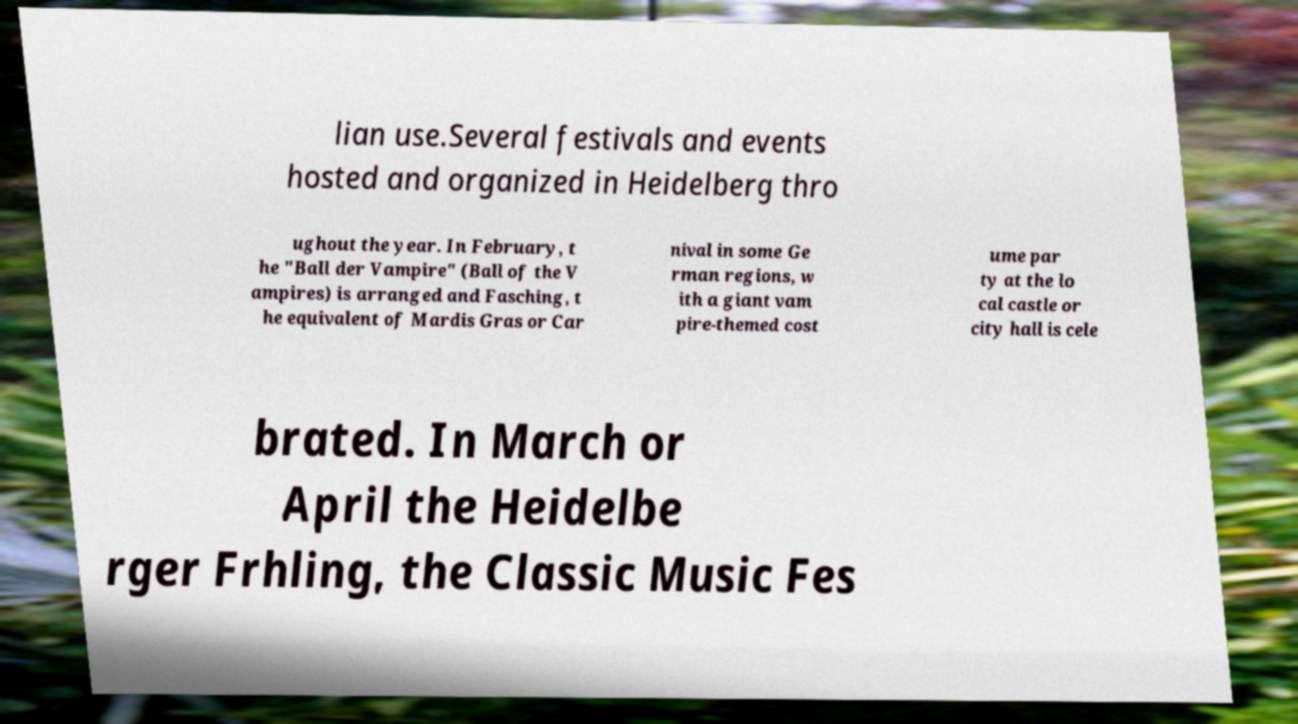Can you read and provide the text displayed in the image?This photo seems to have some interesting text. Can you extract and type it out for me? lian use.Several festivals and events hosted and organized in Heidelberg thro ughout the year. In February, t he "Ball der Vampire" (Ball of the V ampires) is arranged and Fasching, t he equivalent of Mardis Gras or Car nival in some Ge rman regions, w ith a giant vam pire-themed cost ume par ty at the lo cal castle or city hall is cele brated. In March or April the Heidelbe rger Frhling, the Classic Music Fes 